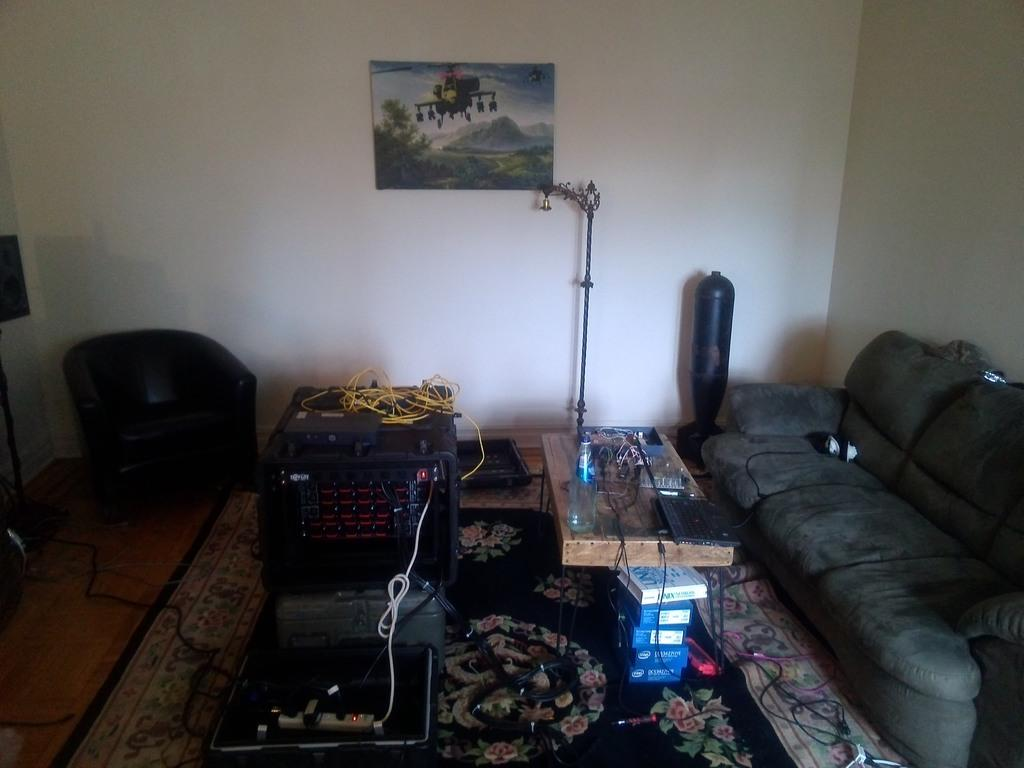What type of furniture is present in the image? There is a sofa set in the image. What else can be seen in the image besides the sofa set? There is an equipment and a table in the image. What is on the table in the image? There are items on the table. What can be seen in the background of the image? There is a wall in the background of the image. What is on the wall in the image? There is a poster on the wall. How far is the distance between the sofa set and the equipment in the image? The provided facts do not include any information about the distance between the sofa set and the equipment, so it cannot be determined from the image. Which direction is the north in relation to the poster on the wall? There is no information about the direction of north in the image, so it cannot be determined. 